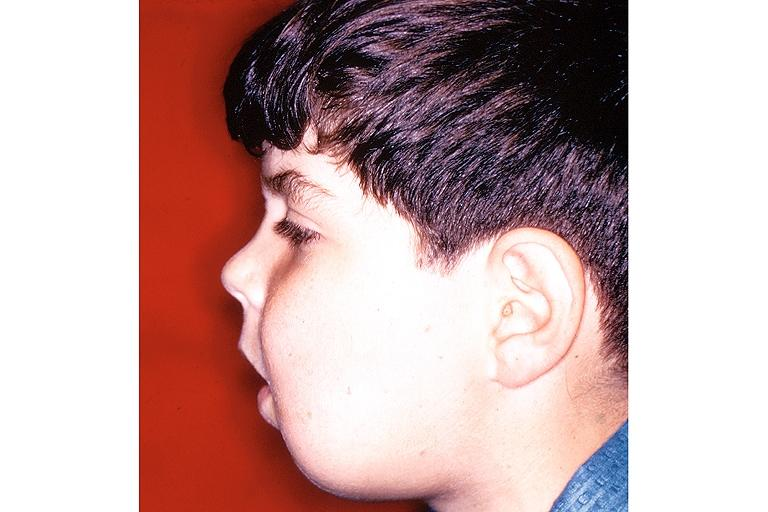does this image show cherubism?
Answer the question using a single word or phrase. Yes 